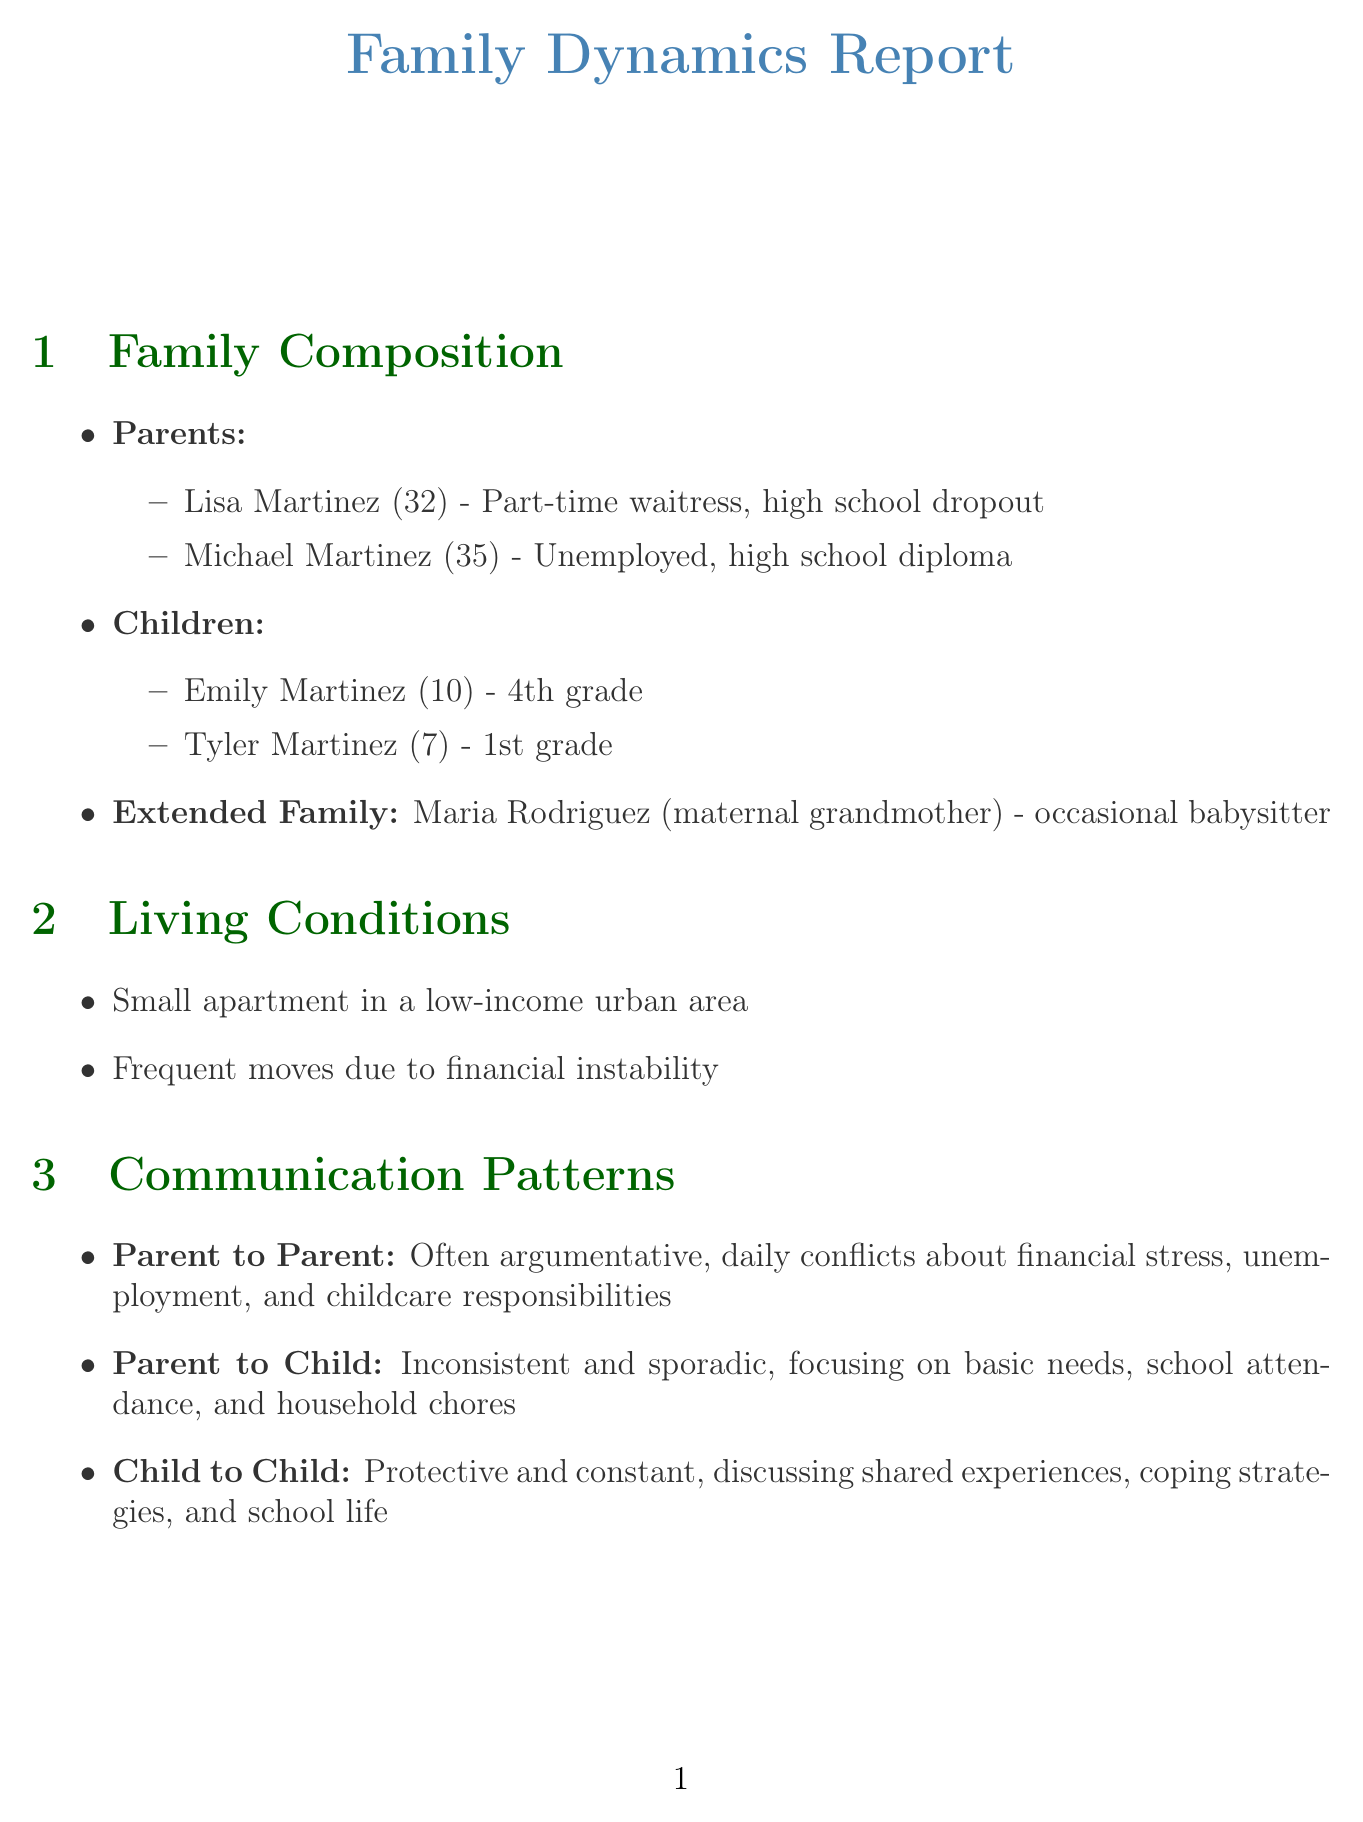what is the age of Lisa Martinez? Lisa Martinez is listed with her age in the family composition section, which shows she is 32 years old.
Answer: 32 how many children does the family have? The family composition section indicates that there are two children: Emily and Tyler.
Answer: 2 what is the primary occupation of Michael Martinez? The family composition states that Michael Martinez is currently unemployed, which is his primary status.
Answer: unemployed what is the style of communication between parents? The communication patterns section describes the parent-to-parent interactions as "often argumentative."
Answer: often argumentative what type of housing do they live in? The living conditions section specifies that they reside in a "small apartment."
Answer: small apartment what is one external support system available to the family? The support systems section provides examples of external support, including access to a "local food bank."
Answer: local food bank how frequently do the parents have conflicts? The communication patterns section reports that the frequency of conflicts between parents is daily.
Answer: daily what is the emotional climate of the family? In the family dynamics section, it describes the emotional climate as "tense and unpredictable."
Answer: tense and unpredictable what government assistance do they receive? The intervention history section mentions the family receives "SNAP benefits."
Answer: SNAP benefits 